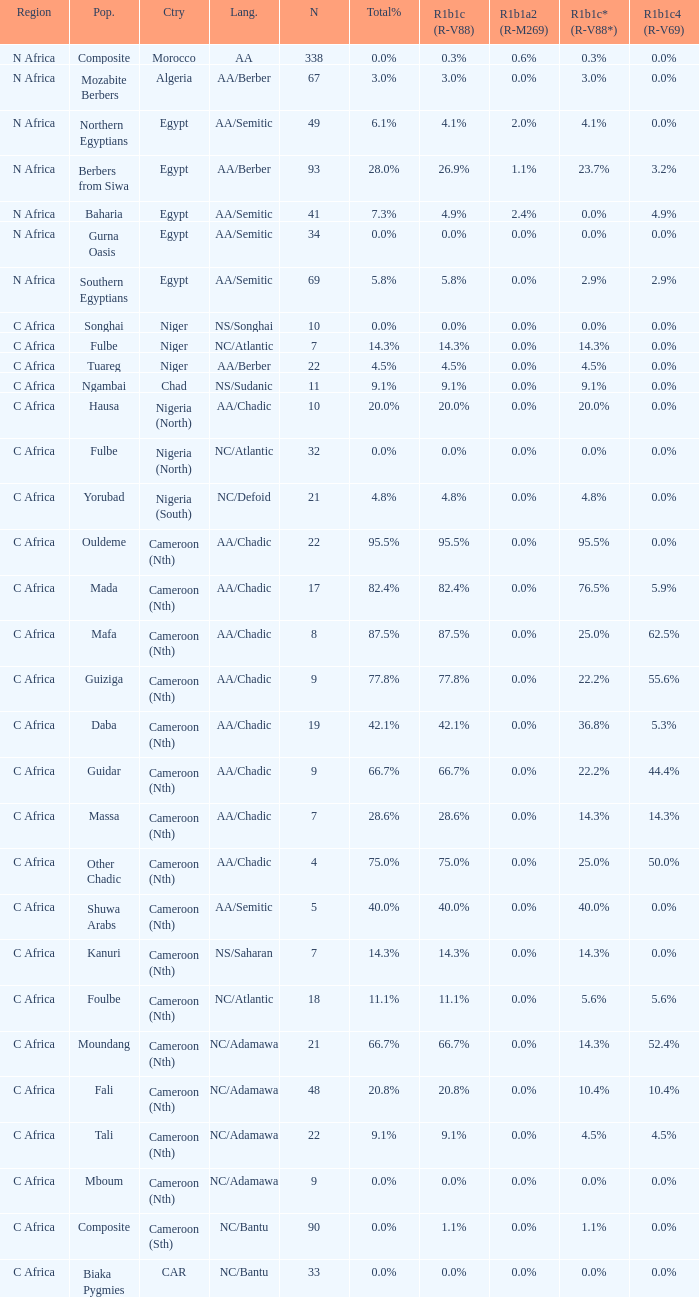What languages are spoken in Niger with r1b1c (r-v88) of 0.0%? NS/Songhai. 